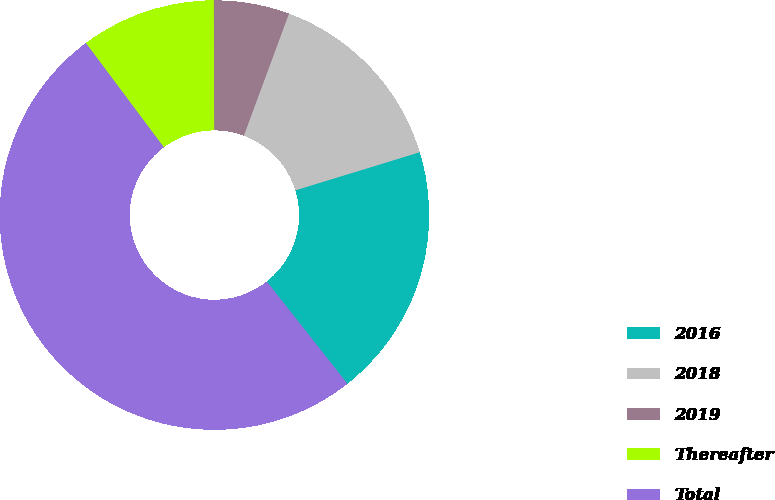Convert chart. <chart><loc_0><loc_0><loc_500><loc_500><pie_chart><fcel>2016<fcel>2018<fcel>2019<fcel>Thereafter<fcel>Total<nl><fcel>19.11%<fcel>14.63%<fcel>5.69%<fcel>10.16%<fcel>50.41%<nl></chart> 